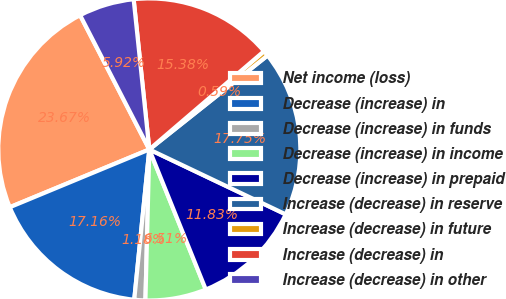Convert chart. <chart><loc_0><loc_0><loc_500><loc_500><pie_chart><fcel>Net income (loss)<fcel>Decrease (increase) in<fcel>Decrease (increase) in funds<fcel>Decrease (increase) in income<fcel>Decrease (increase) in prepaid<fcel>Increase (decrease) in reserve<fcel>Increase (decrease) in future<fcel>Increase (decrease) in<fcel>Increase (decrease) in other<nl><fcel>23.67%<fcel>17.16%<fcel>1.18%<fcel>6.51%<fcel>11.83%<fcel>17.75%<fcel>0.59%<fcel>15.38%<fcel>5.92%<nl></chart> 